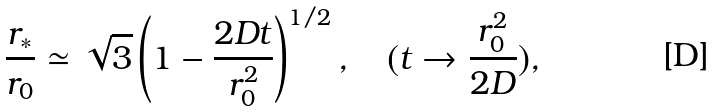Convert formula to latex. <formula><loc_0><loc_0><loc_500><loc_500>\frac { r _ { * } } { r _ { 0 } } \simeq \sqrt { 3 } \left ( 1 - \frac { 2 D t } { r _ { 0 } ^ { 2 } } \right ) ^ { 1 / 2 } , \quad ( t \rightarrow \frac { r _ { 0 } ^ { 2 } } { 2 D } ) ,</formula> 